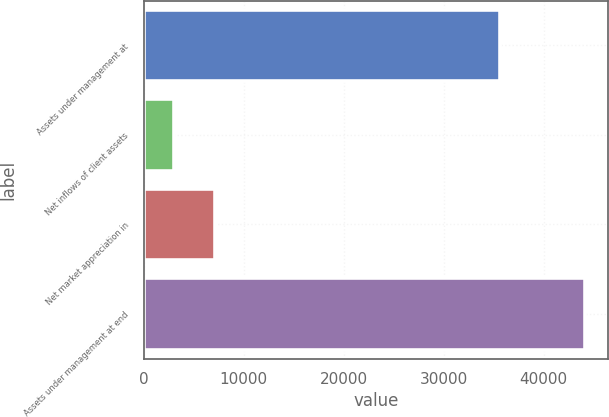Convert chart. <chart><loc_0><loc_0><loc_500><loc_500><bar_chart><fcel>Assets under management at<fcel>Net inflows of client assets<fcel>Net market appreciation in<fcel>Assets under management at end<nl><fcel>35648<fcel>2999<fcel>7115.9<fcel>44168<nl></chart> 